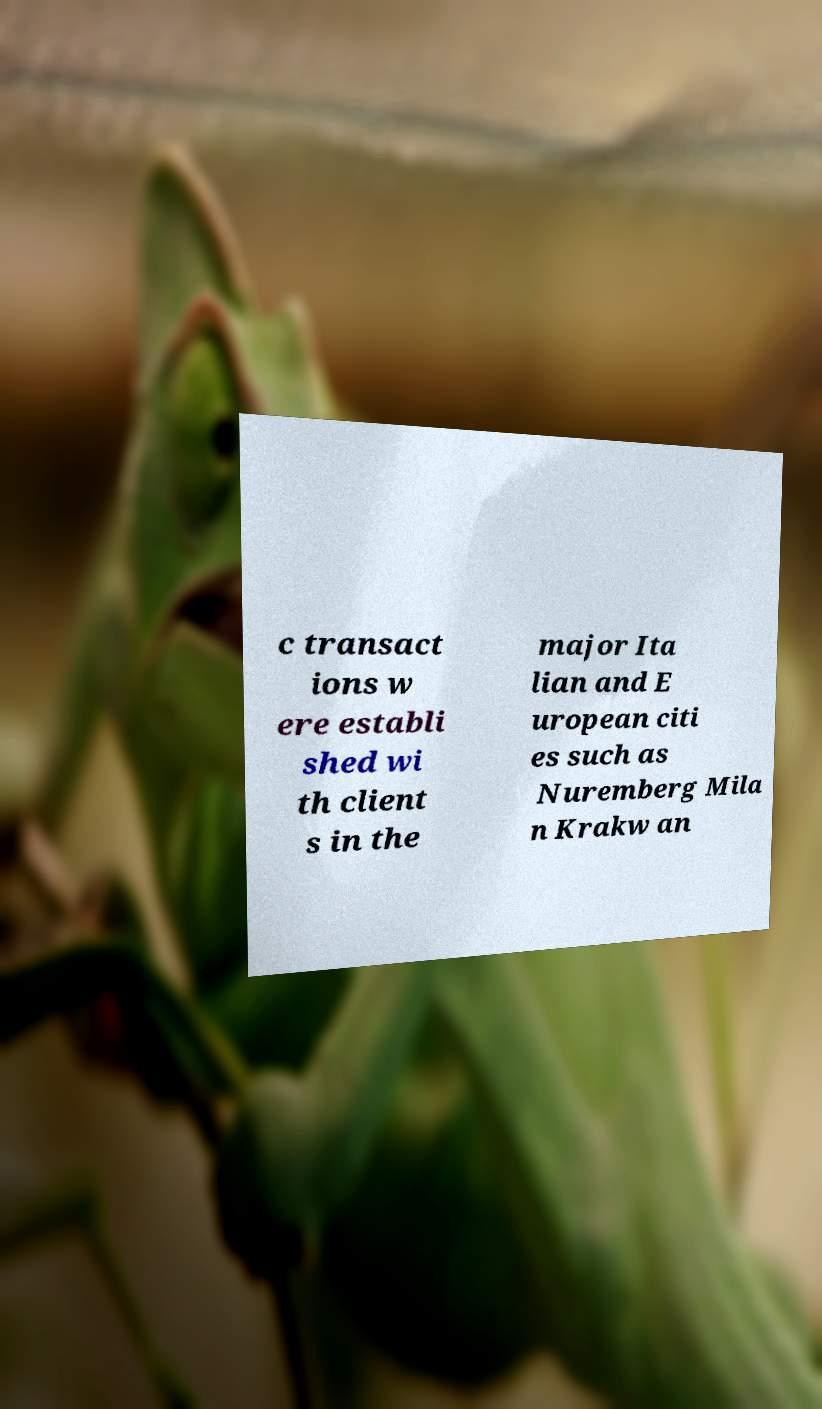There's text embedded in this image that I need extracted. Can you transcribe it verbatim? c transact ions w ere establi shed wi th client s in the major Ita lian and E uropean citi es such as Nuremberg Mila n Krakw an 